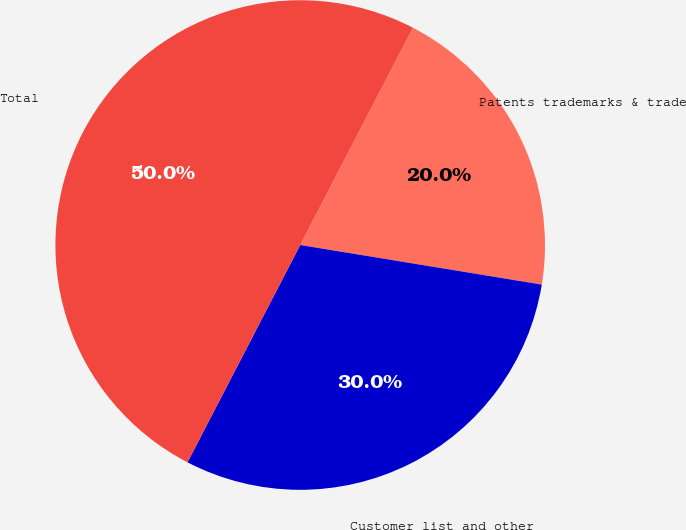<chart> <loc_0><loc_0><loc_500><loc_500><pie_chart><fcel>Patents trademarks & trade<fcel>Customer list and other<fcel>Total<nl><fcel>19.97%<fcel>30.03%<fcel>50.0%<nl></chart> 